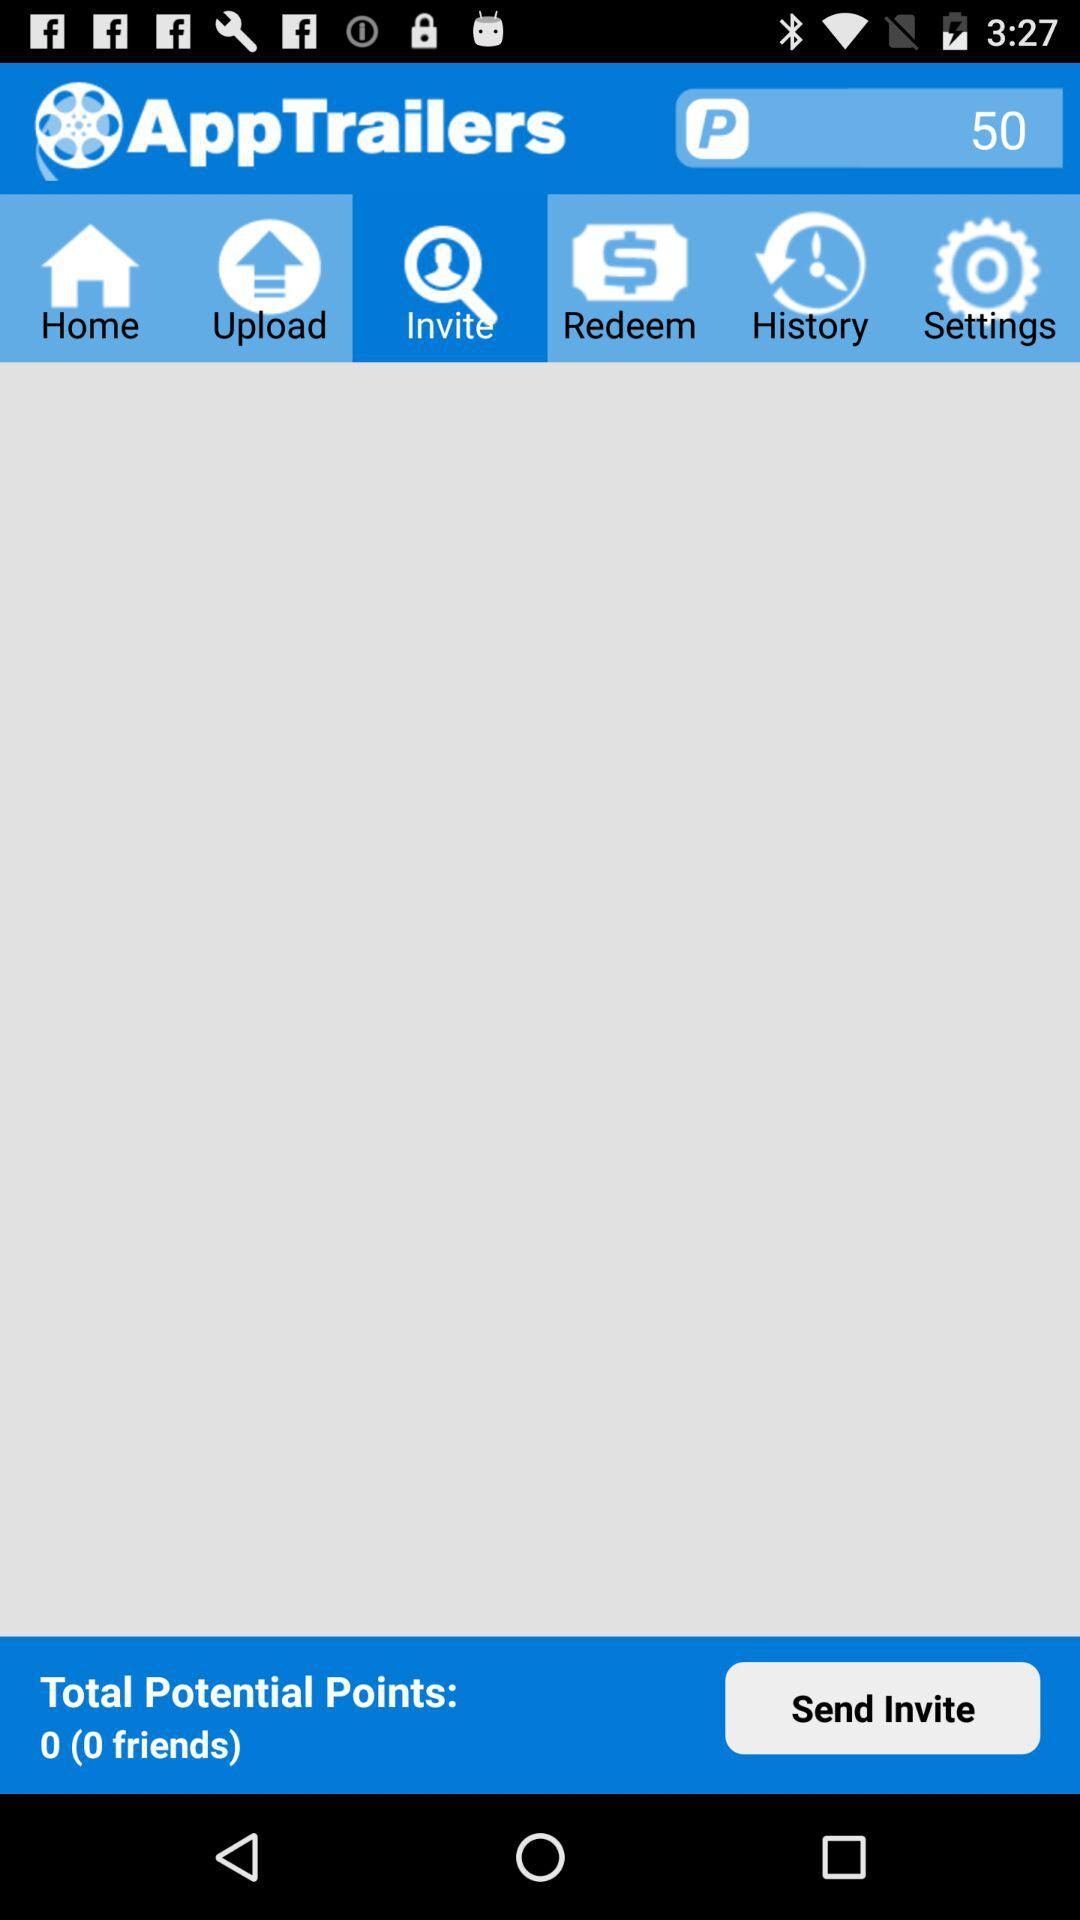Which tab is selected? The selected tab is "Invite". 